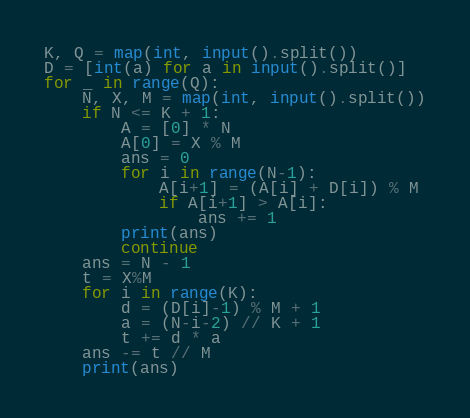<code> <loc_0><loc_0><loc_500><loc_500><_Python_>K, Q = map(int, input().split())
D = [int(a) for a in input().split()]
for _ in range(Q):
    N, X, M = map(int, input().split())
    if N <= K + 1:
        A = [0] * N
        A[0] = X % M
        ans = 0
        for i in range(N-1):
            A[i+1] = (A[i] + D[i]) % M
            if A[i+1] > A[i]:
                ans += 1
        print(ans)
        continue
    ans = N - 1
    t = X%M
    for i in range(K):
        d = (D[i]-1) % M + 1
        a = (N-i-2) // K + 1
        t += d * a
    ans -= t // M
    print(ans)</code> 